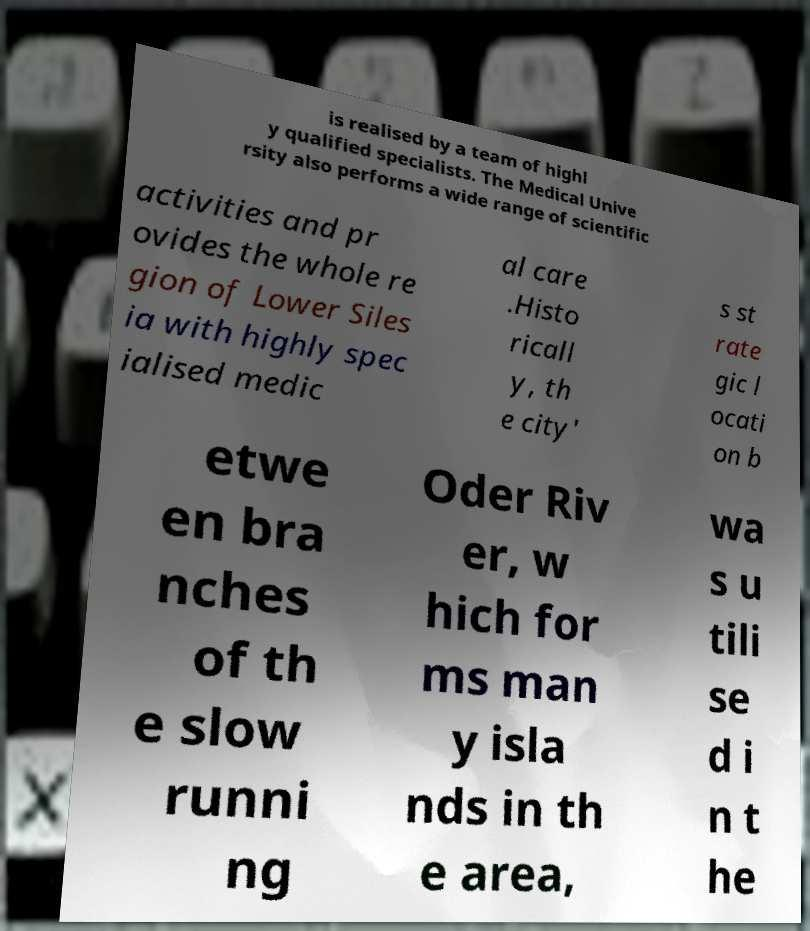Can you read and provide the text displayed in the image?This photo seems to have some interesting text. Can you extract and type it out for me? is realised by a team of highl y qualified specialists. The Medical Unive rsity also performs a wide range of scientific activities and pr ovides the whole re gion of Lower Siles ia with highly spec ialised medic al care .Histo ricall y, th e city' s st rate gic l ocati on b etwe en bra nches of th e slow runni ng Oder Riv er, w hich for ms man y isla nds in th e area, wa s u tili se d i n t he 